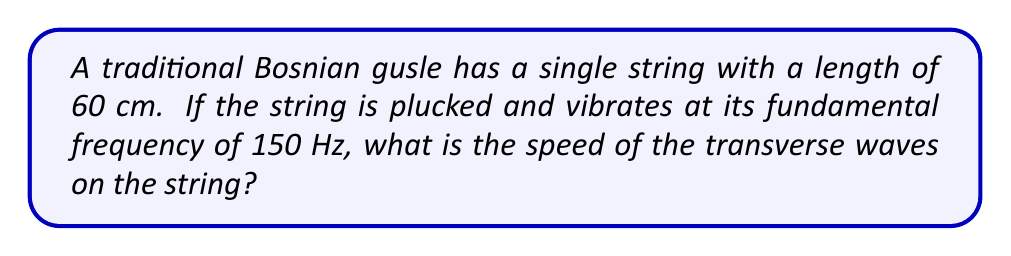Provide a solution to this math problem. Let's approach this step-by-step:

1) The fundamental frequency of a vibrating string is given by the equation:

   $$f = \frac{v}{2L}$$

   Where:
   $f$ is the fundamental frequency
   $v$ is the speed of the wave
   $L$ is the length of the string

2) We are given:
   $f = 150$ Hz
   $L = 60$ cm $= 0.6$ m

3) Let's substitute these values into the equation:

   $$150 = \frac{v}{2(0.6)}$$

4) Now, let's solve for $v$:

   $$150 \cdot 2 \cdot 0.6 = v$$

   $$180 = v$$

5) Therefore, the speed of the transverse waves on the string is 180 m/s.
Answer: 180 m/s 